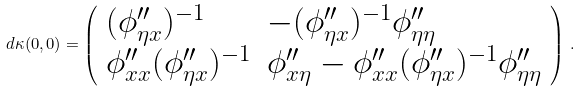Convert formula to latex. <formula><loc_0><loc_0><loc_500><loc_500>d \kappa ( 0 , 0 ) = \left ( \begin{array} { l l } ( \phi ^ { \prime \prime } _ { \eta x } ) ^ { - 1 } & - ( \phi _ { \eta x } ^ { \prime \prime } ) ^ { - 1 } \phi _ { \eta \eta } ^ { \prime \prime } \\ \phi ^ { \prime \prime } _ { x x } ( \phi ^ { \prime \prime } _ { \eta x } ) ^ { - 1 } & \phi ^ { \prime \prime } _ { x \eta } - \phi _ { x x } ^ { \prime \prime } ( \phi ^ { \prime \prime } _ { \eta x } ) ^ { - 1 } \phi ^ { \prime \prime } _ { \eta \eta } \end{array} \right ) \, .</formula> 